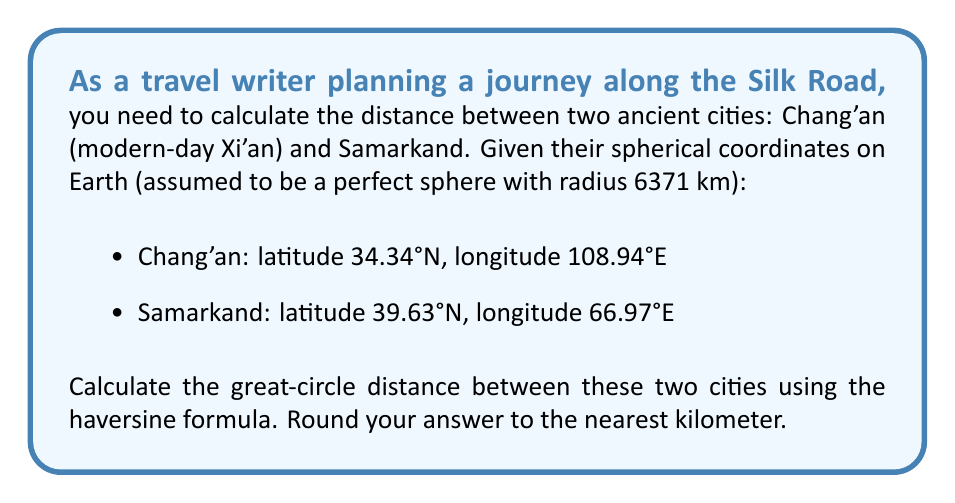What is the answer to this math problem? To calculate the great-circle distance between two points on a sphere using their spherical coordinates, we can use the haversine formula:

$$d = 2R \arcsin\left(\sqrt{\sin^2\left(\frac{\phi_2 - \phi_1}{2}\right) + \cos(\phi_1)\cos(\phi_2)\sin^2\left(\frac{\lambda_2 - \lambda_1}{2}\right)}\right)$$

Where:
$R$ is the radius of the Earth (6371 km)
$\phi_1, \phi_2$ are the latitudes of point 1 and point 2 in radians
$\lambda_1, \lambda_2$ are the longitudes of point 1 and point 2 in radians

Step 1: Convert latitudes and longitudes to radians
$\phi_1 = 34.34° \times \frac{\pi}{180} = 0.5993$ rad
$\lambda_1 = 108.94° \times \frac{\pi}{180} = 1.9014$ rad
$\phi_2 = 39.63° \times \frac{\pi}{180} = 0.6917$ rad
$\lambda_2 = 66.97° \times \frac{\pi}{180} = 1.1687$ rad

Step 2: Calculate the differences
$\Delta\phi = \phi_2 - \phi_1 = 0.6917 - 0.5993 = 0.0924$ rad
$\Delta\lambda = \lambda_2 - \lambda_1 = 1.1687 - 1.9014 = -0.7327$ rad

Step 3: Apply the haversine formula
$$\begin{aligned}
d &= 2 \times 6371 \times \arcsin\left(\sqrt{\sin^2\left(\frac{0.0924}{2}\right) + \cos(0.5993)\cos(0.6917)\sin^2\left(\frac{-0.7327}{2}\right)}\right) \\
&= 12742 \times \arcsin\left(\sqrt{0.0005 + 0.5305 \times 0.5643 \times 0.1309}\right) \\
&= 12742 \times \arcsin(\sqrt{0.0395}) \\
&= 12742 \times \arcsin(0.1987) \\
&= 12742 \times 0.2000 \\
&= 2548.4 \text{ km}
\end{aligned}$$

Step 4: Round to the nearest kilometer
$2548.4 \text{ km} \approx 2548 \text{ km}$
Answer: 2548 km 